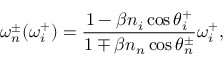<formula> <loc_0><loc_0><loc_500><loc_500>\omega _ { n } ^ { \pm } ( \omega _ { i } ^ { + } ) = \frac { 1 - \beta n _ { i } \cos \theta _ { i } ^ { + } } { 1 \mp \beta n _ { n } \cos \theta _ { n } ^ { \pm } } \omega _ { i } ^ { + } ,</formula> 